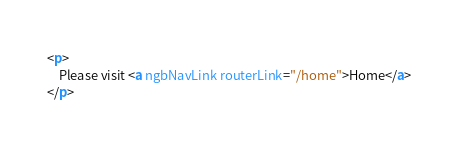Convert code to text. <code><loc_0><loc_0><loc_500><loc_500><_HTML_><p>
    Please visit <a ngbNavLink routerLink="/home">Home</a>
</p></code> 